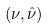<formula> <loc_0><loc_0><loc_500><loc_500>( \nu , \hat { \nu } )</formula> 